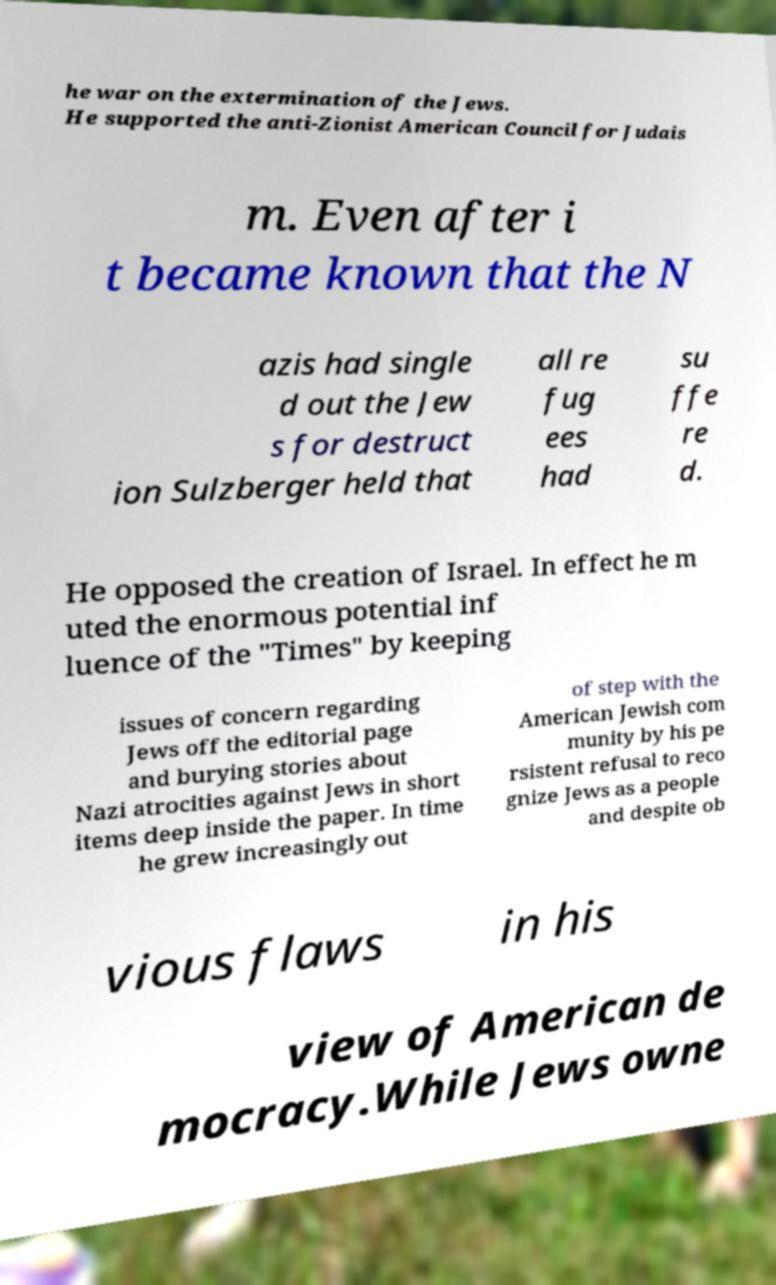Can you read and provide the text displayed in the image?This photo seems to have some interesting text. Can you extract and type it out for me? he war on the extermination of the Jews. He supported the anti-Zionist American Council for Judais m. Even after i t became known that the N azis had single d out the Jew s for destruct ion Sulzberger held that all re fug ees had su ffe re d. He opposed the creation of Israel. In effect he m uted the enormous potential inf luence of the "Times" by keeping issues of concern regarding Jews off the editorial page and burying stories about Nazi atrocities against Jews in short items deep inside the paper. In time he grew increasingly out of step with the American Jewish com munity by his pe rsistent refusal to reco gnize Jews as a people and despite ob vious flaws in his view of American de mocracy.While Jews owne 